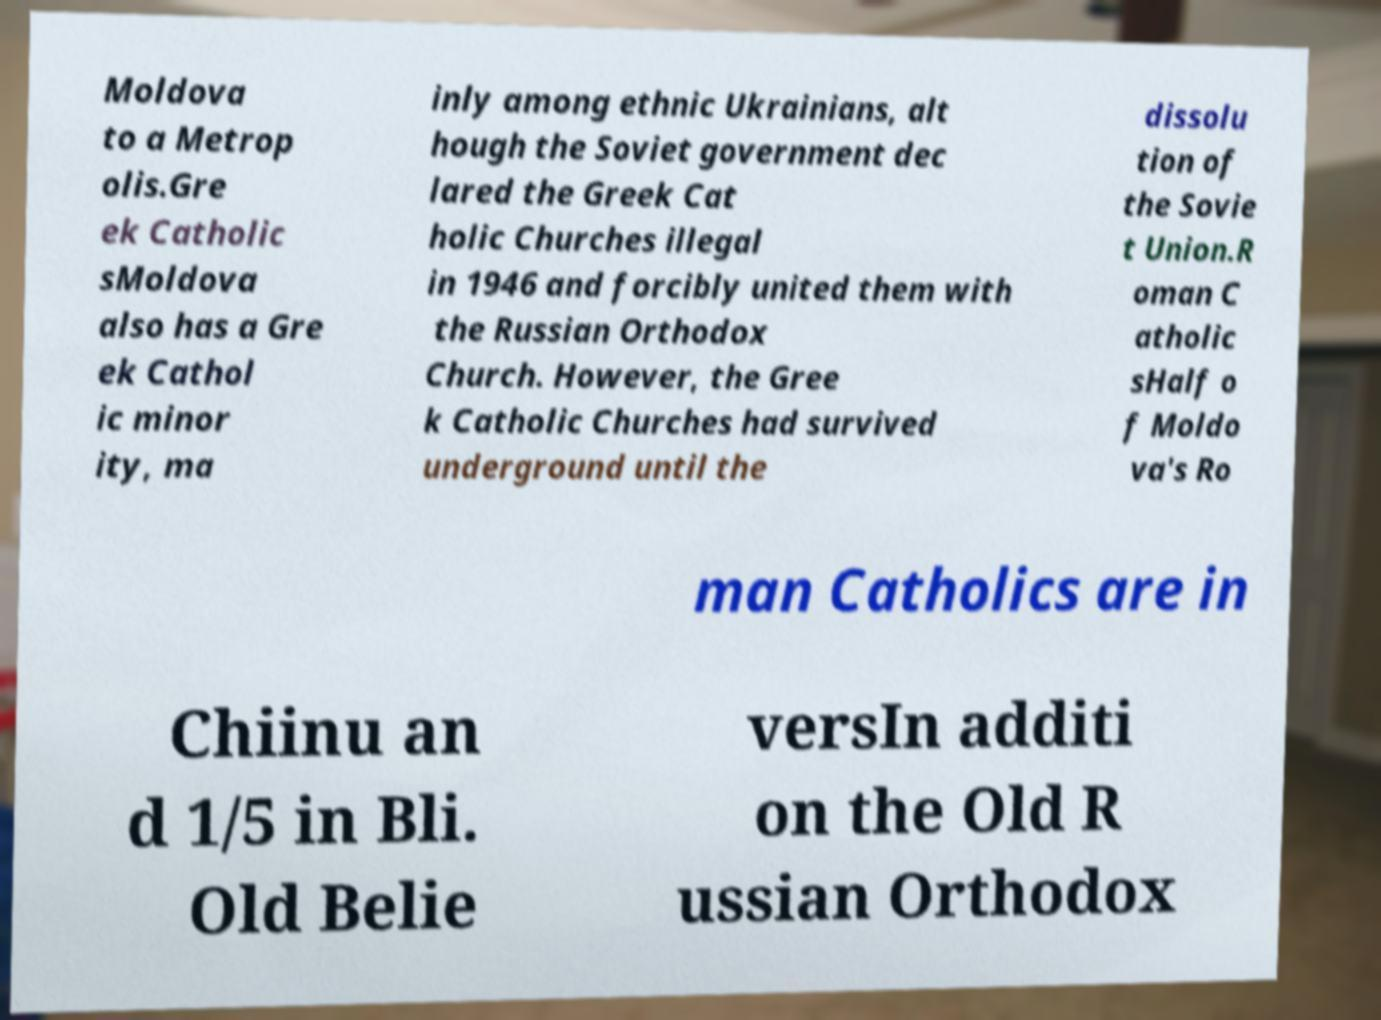There's text embedded in this image that I need extracted. Can you transcribe it verbatim? Moldova to a Metrop olis.Gre ek Catholic sMoldova also has a Gre ek Cathol ic minor ity, ma inly among ethnic Ukrainians, alt hough the Soviet government dec lared the Greek Cat holic Churches illegal in 1946 and forcibly united them with the Russian Orthodox Church. However, the Gree k Catholic Churches had survived underground until the dissolu tion of the Sovie t Union.R oman C atholic sHalf o f Moldo va's Ro man Catholics are in Chiinu an d 1/5 in Bli. Old Belie versIn additi on the Old R ussian Orthodox 